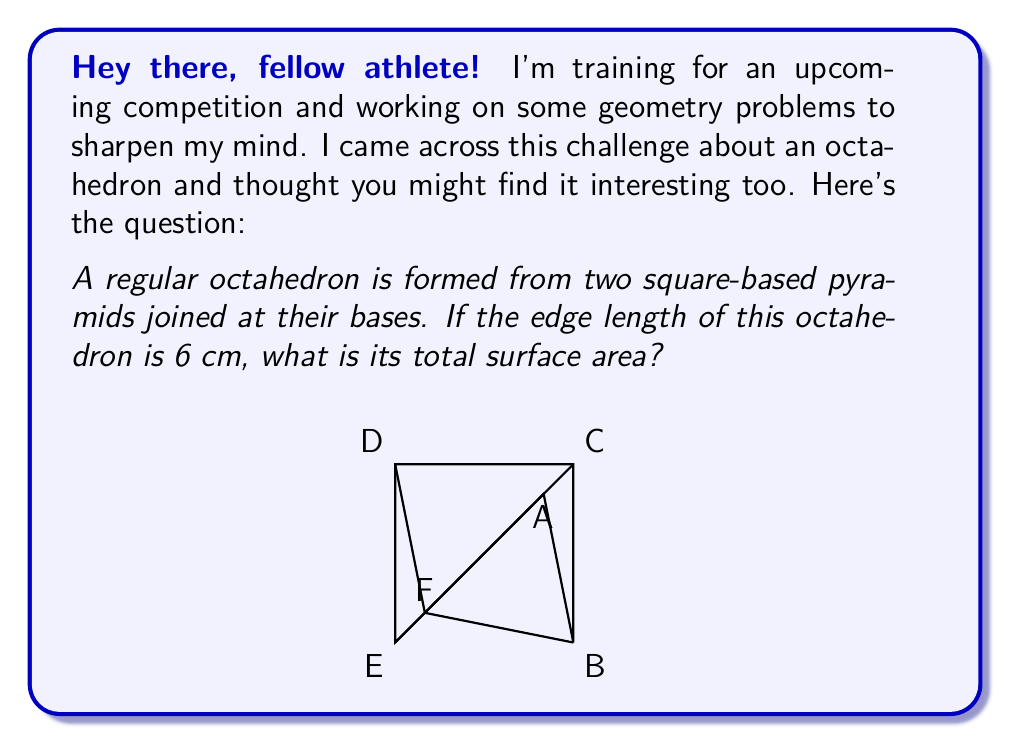Solve this math problem. Great question! Let's break this down step-by-step:

1) A regular octahedron consists of 8 equilateral triangular faces.

2) To find the surface area, we need to calculate the area of one triangular face and multiply it by 8.

3) The edge length of the octahedron is given as 6 cm. This is also the side length of each equilateral triangle.

4) For an equilateral triangle with side length $a$, the area is given by the formula:

   $$A = \frac{\sqrt{3}}{4}a^2$$

5) Substituting $a = 6$ cm:

   $$A = \frac{\sqrt{3}}{4}(6^2) = \frac{\sqrt{3}}{4}(36) = 9\sqrt{3} \text{ cm}^2$$

6) This is the area of one face. For the total surface area, we multiply by 8:

   $$\text{Total Surface Area} = 8(9\sqrt{3}) = 72\sqrt{3} \text{ cm}^2$$

Therefore, the total surface area of the octahedron is $72\sqrt{3} \text{ cm}^2$.
Answer: $72\sqrt{3} \text{ cm}^2$ 